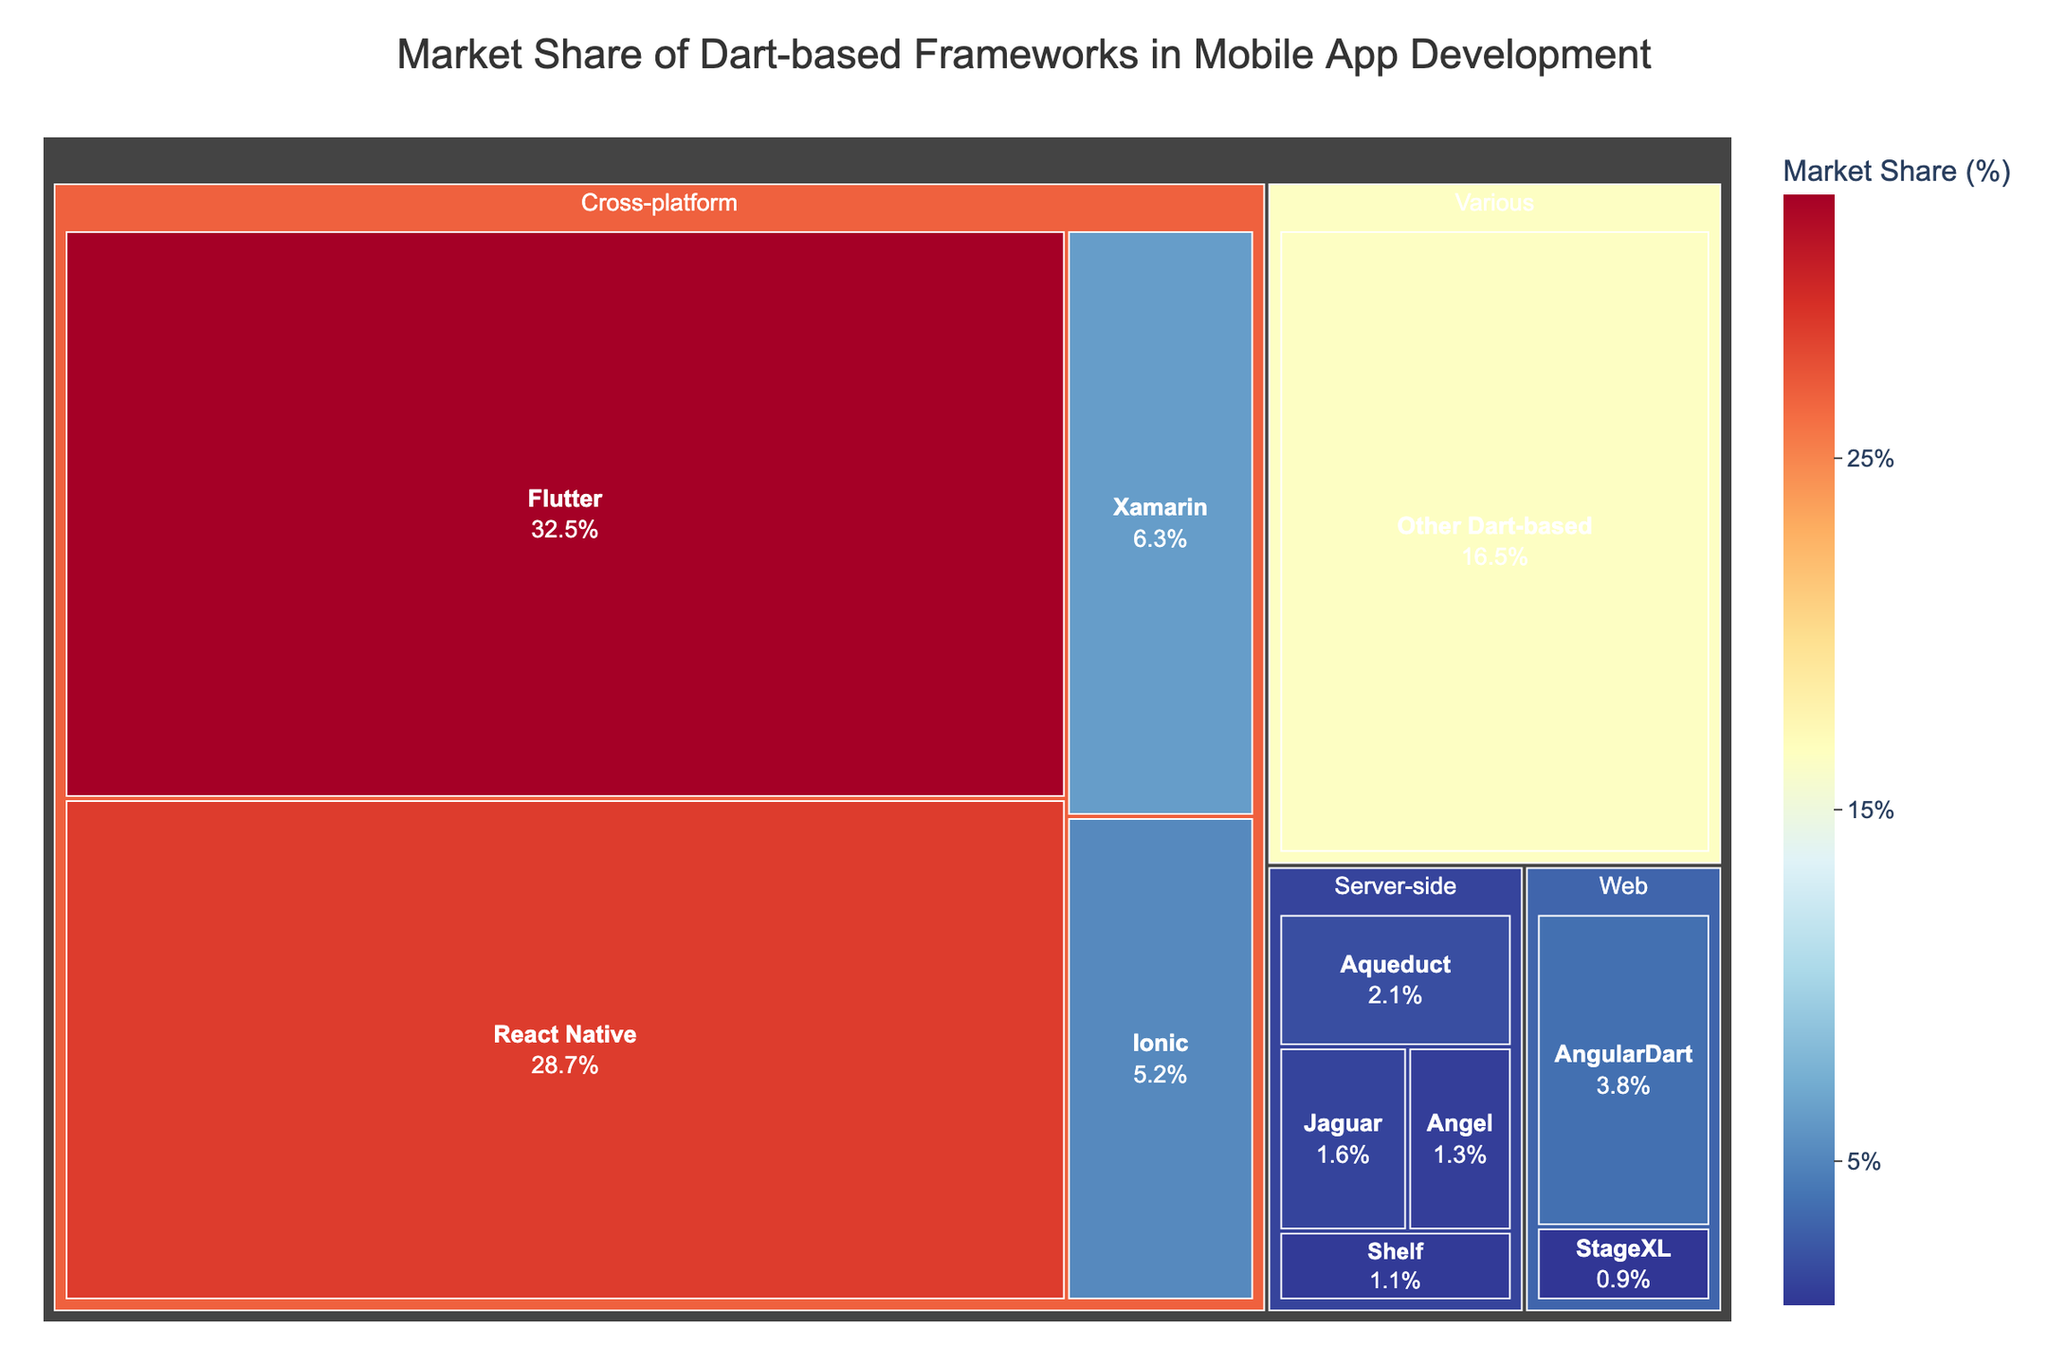What is the largest Dart-based framework in the market share? The largest framework can be found by comparing the market share values of all frameworks. Flutter has the highest market share of 32.5%.
Answer: Flutter What is the combined market share of server-side Dart-based frameworks? To find the combined market share of server-side frameworks, sum the market share values of Aqueduct (2.1%), Jaguar (1.6%), Angel (1.3%), and Shelf (1.1%). Summing these values gives: 2.1% + 1.6% + 1.3% + 1.1% = 6.1%.
Answer: 6.1% Which category has the highest number of frameworks? By counting the frameworks in each category, we observe that the Cross-platform category has the most frameworks: Flutter, React Native, Xamarin, and Ionic, totaling 4 frameworks.
Answer: Cross-platform How does the market share of AngularDart compare to the average market share of the Cross-platform frameworks? Calculate the average market share of the Cross-platform frameworks (Flutter, React Native, Xamarin, and Ionic) which sums to 32.5% + 28.7% + 6.3% + 5.2% = 72.7%. The average is 72.7% / 4 = 18.175%. AngularDart's market share is 3.8%, which is significantly lower than 18.175%.
Answer: Lower What percentage of the market is occupied by Dart-based frameworks not listed individually in the tree map? The value for "Other Dart-based" frameworks is provided directly in the data, which is 16.5%.
Answer: 16.5% Is there a framework in the Web category with a market share higher than any server-side framework? AngularDart in the Web category has a market share of 3.8%, which is higher than the market shares of all listed server-side frameworks: Aqueduct (2.1%), Jaguar (1.6%), Angel (1.3%), and Shelf (1.1%).
Answer: Yes Which framework has the smallest market share and what is its share? The smallest market share can be identified by comparing all values. Shelf has the smallest market share at 1.1%.
Answer: Shelf, 1.1% How does Ionic's market share compare to the combined market share of AngularDart and StageXL? Compare Ionic's market share of 5.2% to the sum of AngularDart's (3.8%) and StageXL's (0.9%) which totals 4.7%. Therefore, Ionic's market share (5.2%) is greater than the combined market share of AngularDart and StageXL (4.7%).
Answer: Greater What is the total market share of Cross-platform frameworks? By summing the market shares of all Cross-platform frameworks: Flutter (32.5%), React Native (28.7%), Xamarin (6.3%), and Ionic (5.2%), the total market share is 32.5% + 28.7% + 6.3% + 5.2% = 72.7%.
Answer: 72.7% What is the market share difference between Flutter and React Native? Subtract React Native's market share (28.7%) from Flutter's market share (32.5%). The difference is 32.5% - 28.7% = 3.8%.
Answer: 3.8% 